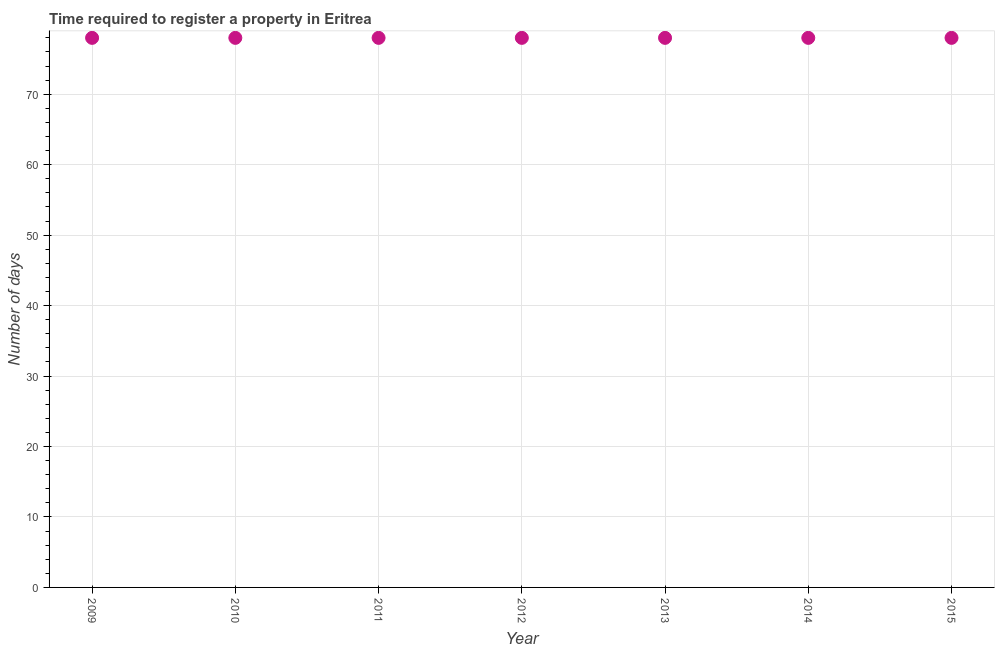What is the number of days required to register property in 2013?
Offer a very short reply. 78. Across all years, what is the maximum number of days required to register property?
Your response must be concise. 78. Across all years, what is the minimum number of days required to register property?
Ensure brevity in your answer.  78. In which year was the number of days required to register property maximum?
Offer a very short reply. 2009. What is the sum of the number of days required to register property?
Your answer should be compact. 546. What is the difference between the number of days required to register property in 2012 and 2013?
Ensure brevity in your answer.  0. What is the average number of days required to register property per year?
Your answer should be very brief. 78. What is the median number of days required to register property?
Provide a succinct answer. 78. What is the ratio of the number of days required to register property in 2010 to that in 2015?
Keep it short and to the point. 1. Is the number of days required to register property in 2009 less than that in 2011?
Offer a terse response. No. What is the difference between the highest and the second highest number of days required to register property?
Your answer should be compact. 0. What is the difference between the highest and the lowest number of days required to register property?
Offer a terse response. 0. In how many years, is the number of days required to register property greater than the average number of days required to register property taken over all years?
Ensure brevity in your answer.  0. Does the number of days required to register property monotonically increase over the years?
Offer a terse response. No. How many dotlines are there?
Provide a short and direct response. 1. How many years are there in the graph?
Your answer should be very brief. 7. Does the graph contain grids?
Your answer should be compact. Yes. What is the title of the graph?
Provide a succinct answer. Time required to register a property in Eritrea. What is the label or title of the X-axis?
Keep it short and to the point. Year. What is the label or title of the Y-axis?
Your response must be concise. Number of days. What is the Number of days in 2009?
Make the answer very short. 78. What is the Number of days in 2011?
Your response must be concise. 78. What is the Number of days in 2013?
Make the answer very short. 78. What is the Number of days in 2015?
Provide a succinct answer. 78. What is the difference between the Number of days in 2009 and 2011?
Provide a short and direct response. 0. What is the difference between the Number of days in 2009 and 2013?
Provide a short and direct response. 0. What is the difference between the Number of days in 2010 and 2012?
Your answer should be compact. 0. What is the difference between the Number of days in 2010 and 2013?
Keep it short and to the point. 0. What is the difference between the Number of days in 2011 and 2012?
Ensure brevity in your answer.  0. What is the difference between the Number of days in 2011 and 2014?
Provide a succinct answer. 0. What is the difference between the Number of days in 2011 and 2015?
Your answer should be very brief. 0. What is the difference between the Number of days in 2012 and 2013?
Ensure brevity in your answer.  0. What is the difference between the Number of days in 2013 and 2014?
Provide a succinct answer. 0. What is the difference between the Number of days in 2014 and 2015?
Your response must be concise. 0. What is the ratio of the Number of days in 2009 to that in 2010?
Keep it short and to the point. 1. What is the ratio of the Number of days in 2009 to that in 2011?
Your response must be concise. 1. What is the ratio of the Number of days in 2009 to that in 2012?
Ensure brevity in your answer.  1. What is the ratio of the Number of days in 2009 to that in 2013?
Provide a succinct answer. 1. What is the ratio of the Number of days in 2009 to that in 2015?
Your answer should be compact. 1. What is the ratio of the Number of days in 2010 to that in 2013?
Your answer should be very brief. 1. What is the ratio of the Number of days in 2010 to that in 2014?
Your answer should be compact. 1. What is the ratio of the Number of days in 2011 to that in 2012?
Give a very brief answer. 1. What is the ratio of the Number of days in 2011 to that in 2013?
Offer a very short reply. 1. What is the ratio of the Number of days in 2011 to that in 2015?
Ensure brevity in your answer.  1. What is the ratio of the Number of days in 2012 to that in 2013?
Offer a terse response. 1. What is the ratio of the Number of days in 2012 to that in 2014?
Offer a very short reply. 1. 